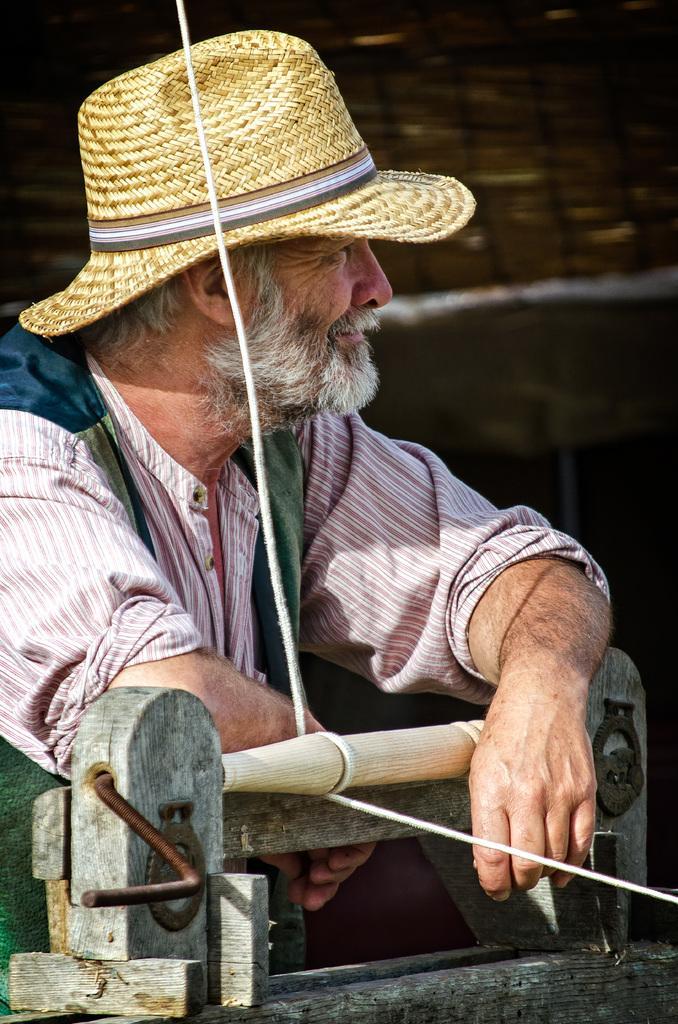Please provide a concise description of this image. In this image we can see a man wearing a hat standing beside a device with a rope. 